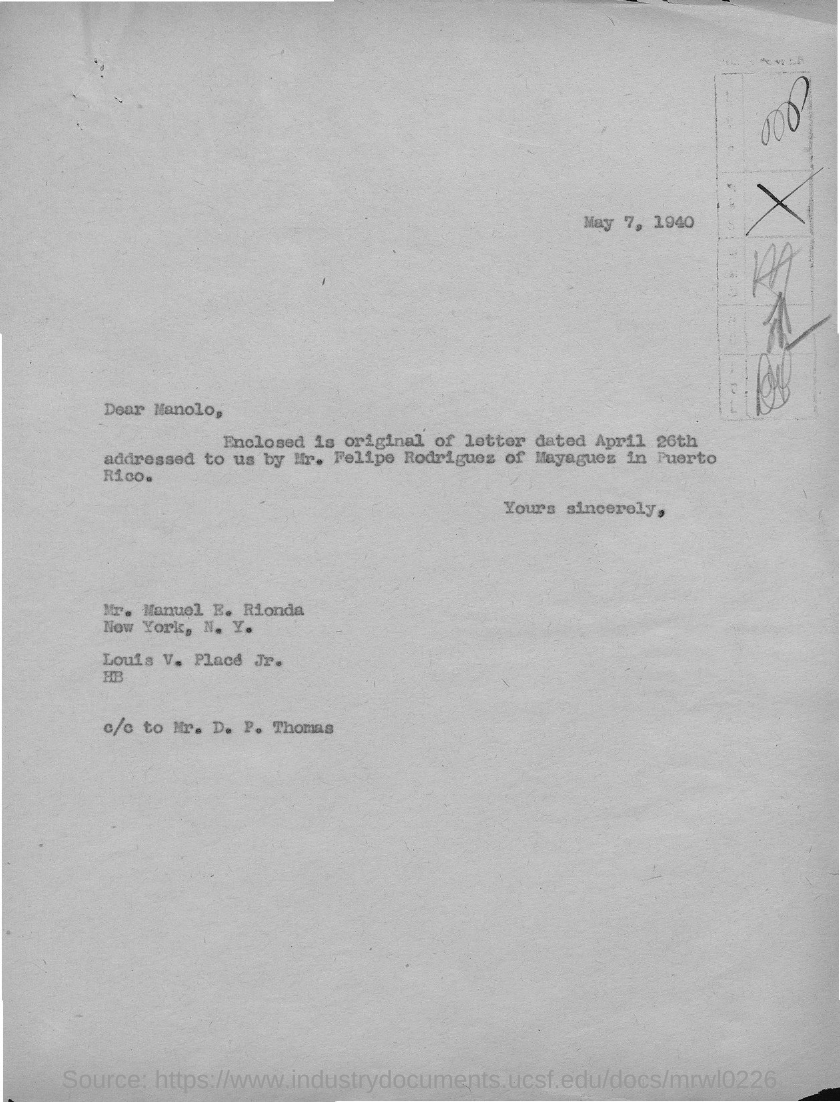Who is the sender of this letter?
Offer a terse response. Mr. Manuel E. Rionda. What is the issued date of this letter?
Ensure brevity in your answer.  May 7, 1940. Who is the addressee of this letter?
Your answer should be compact. Manolo. 